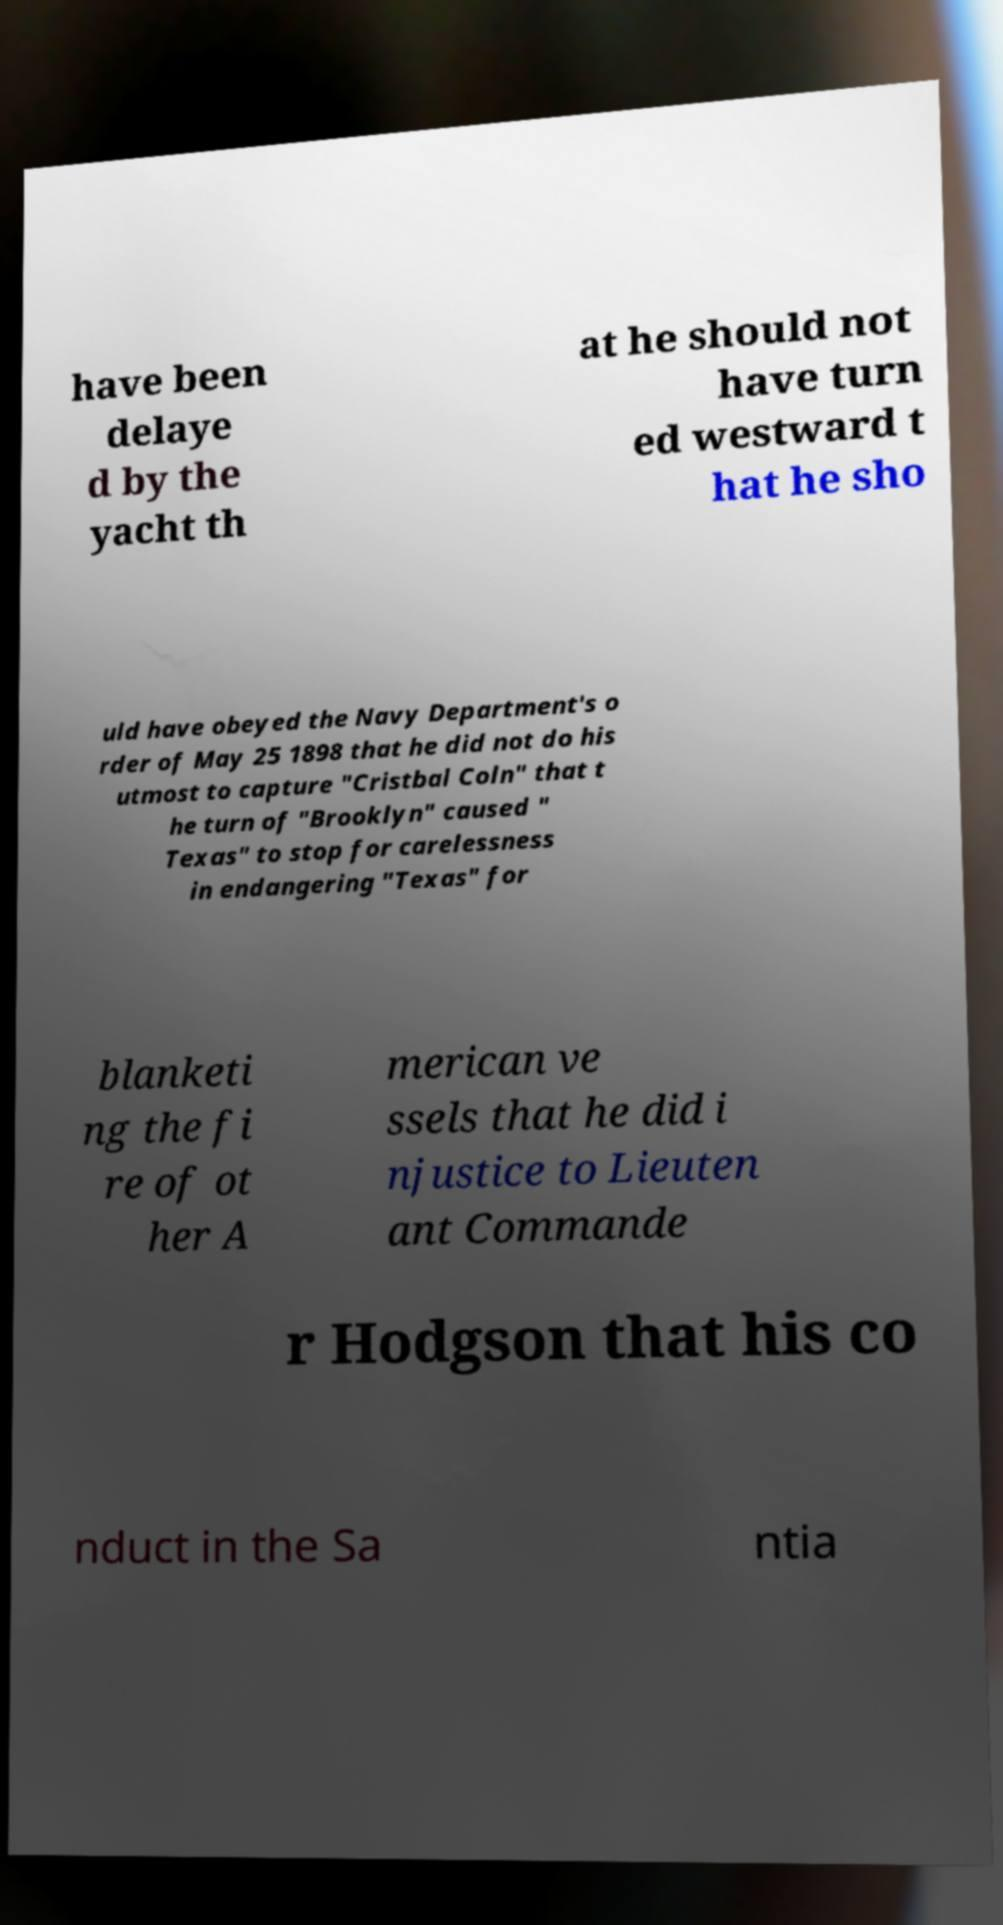Could you assist in decoding the text presented in this image and type it out clearly? have been delaye d by the yacht th at he should not have turn ed westward t hat he sho uld have obeyed the Navy Department's o rder of May 25 1898 that he did not do his utmost to capture "Cristbal Coln" that t he turn of "Brooklyn" caused " Texas" to stop for carelessness in endangering "Texas" for blanketi ng the fi re of ot her A merican ve ssels that he did i njustice to Lieuten ant Commande r Hodgson that his co nduct in the Sa ntia 